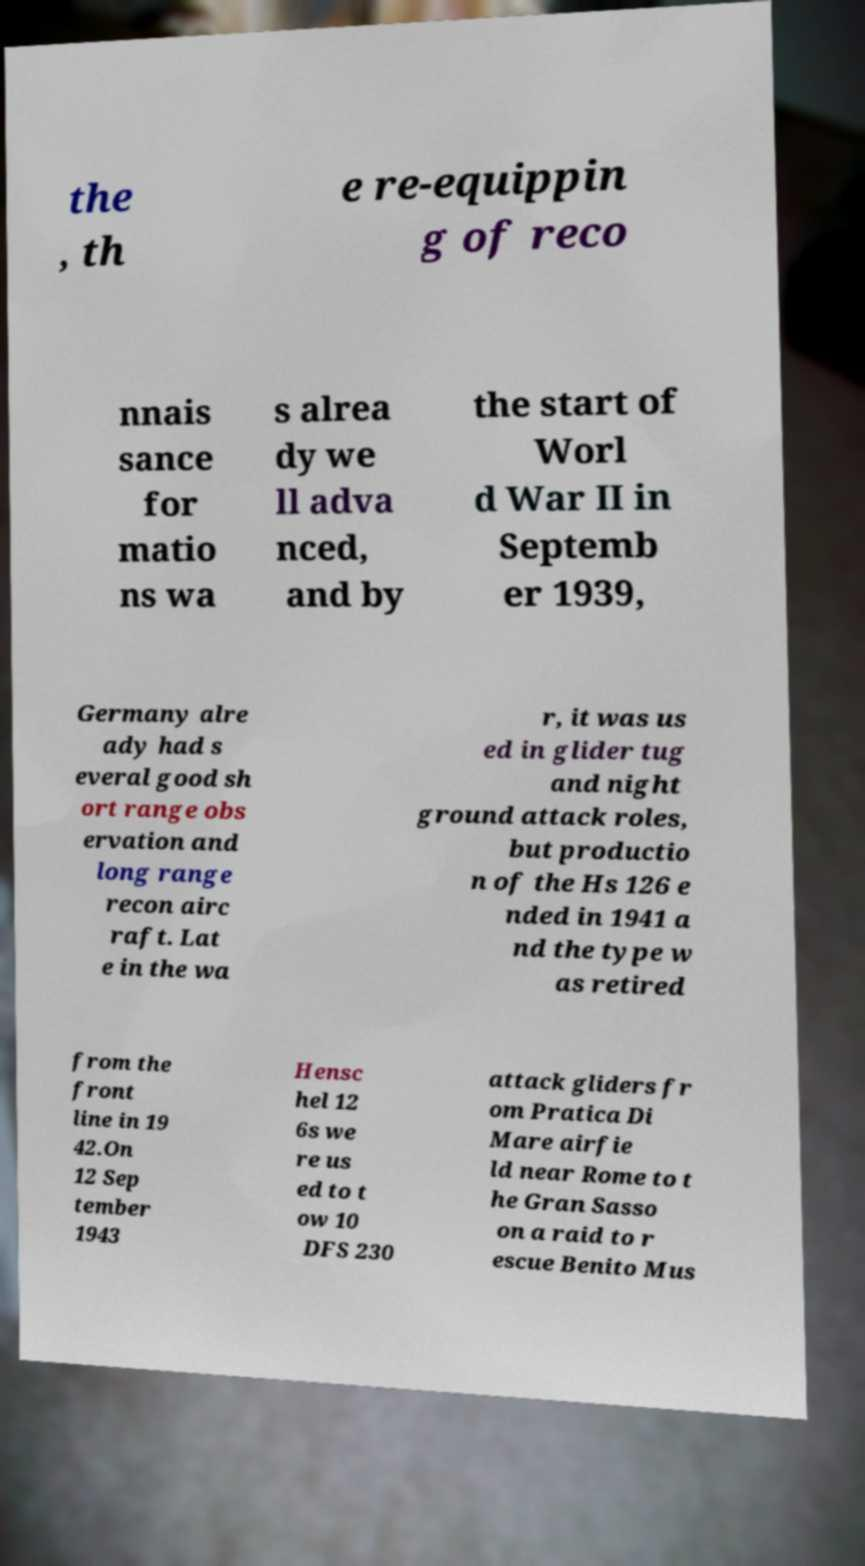Can you read and provide the text displayed in the image?This photo seems to have some interesting text. Can you extract and type it out for me? the , th e re-equippin g of reco nnais sance for matio ns wa s alrea dy we ll adva nced, and by the start of Worl d War II in Septemb er 1939, Germany alre ady had s everal good sh ort range obs ervation and long range recon airc raft. Lat e in the wa r, it was us ed in glider tug and night ground attack roles, but productio n of the Hs 126 e nded in 1941 a nd the type w as retired from the front line in 19 42.On 12 Sep tember 1943 Hensc hel 12 6s we re us ed to t ow 10 DFS 230 attack gliders fr om Pratica Di Mare airfie ld near Rome to t he Gran Sasso on a raid to r escue Benito Mus 